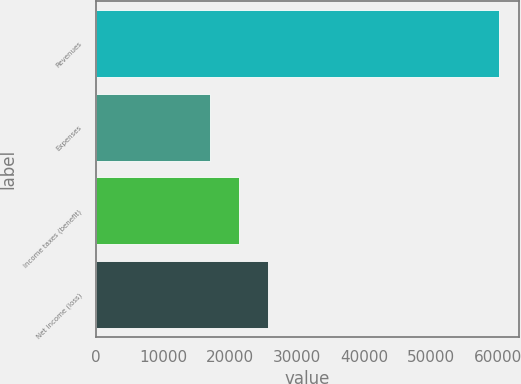<chart> <loc_0><loc_0><loc_500><loc_500><bar_chart><fcel>Revenues<fcel>Expenses<fcel>Income taxes (benefit)<fcel>Net income (loss)<nl><fcel>60195<fcel>16950<fcel>21274.5<fcel>25649<nl></chart> 